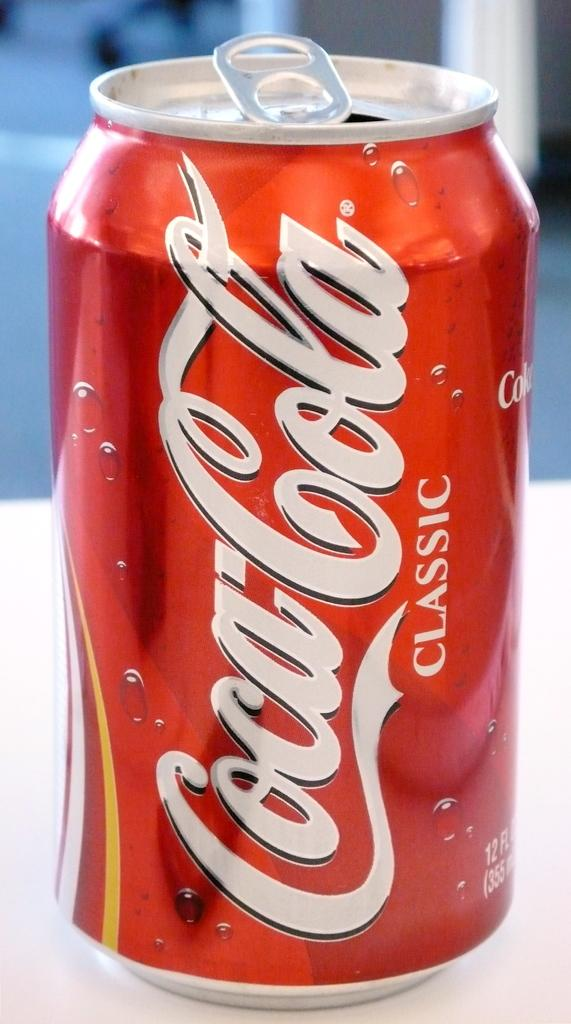<image>
Share a concise interpretation of the image provided. Opened red and white Coca Cola can on top of a table. 